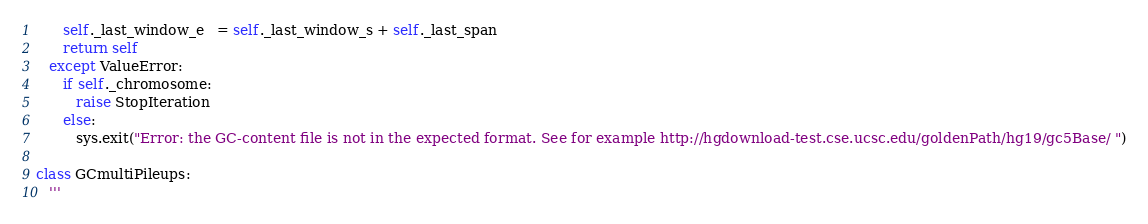Convert code to text. <code><loc_0><loc_0><loc_500><loc_500><_Python_>      self._last_window_e   = self._last_window_s + self._last_span
      return self
   except ValueError:
      if self._chromosome:
         raise StopIteration
      else:
         sys.exit("Error: the GC-content file is not in the expected format. See for example http://hgdownload-test.cse.ucsc.edu/goldenPath/hg19/gc5Base/ ")

class GCmultiPileups:
   '''</code> 